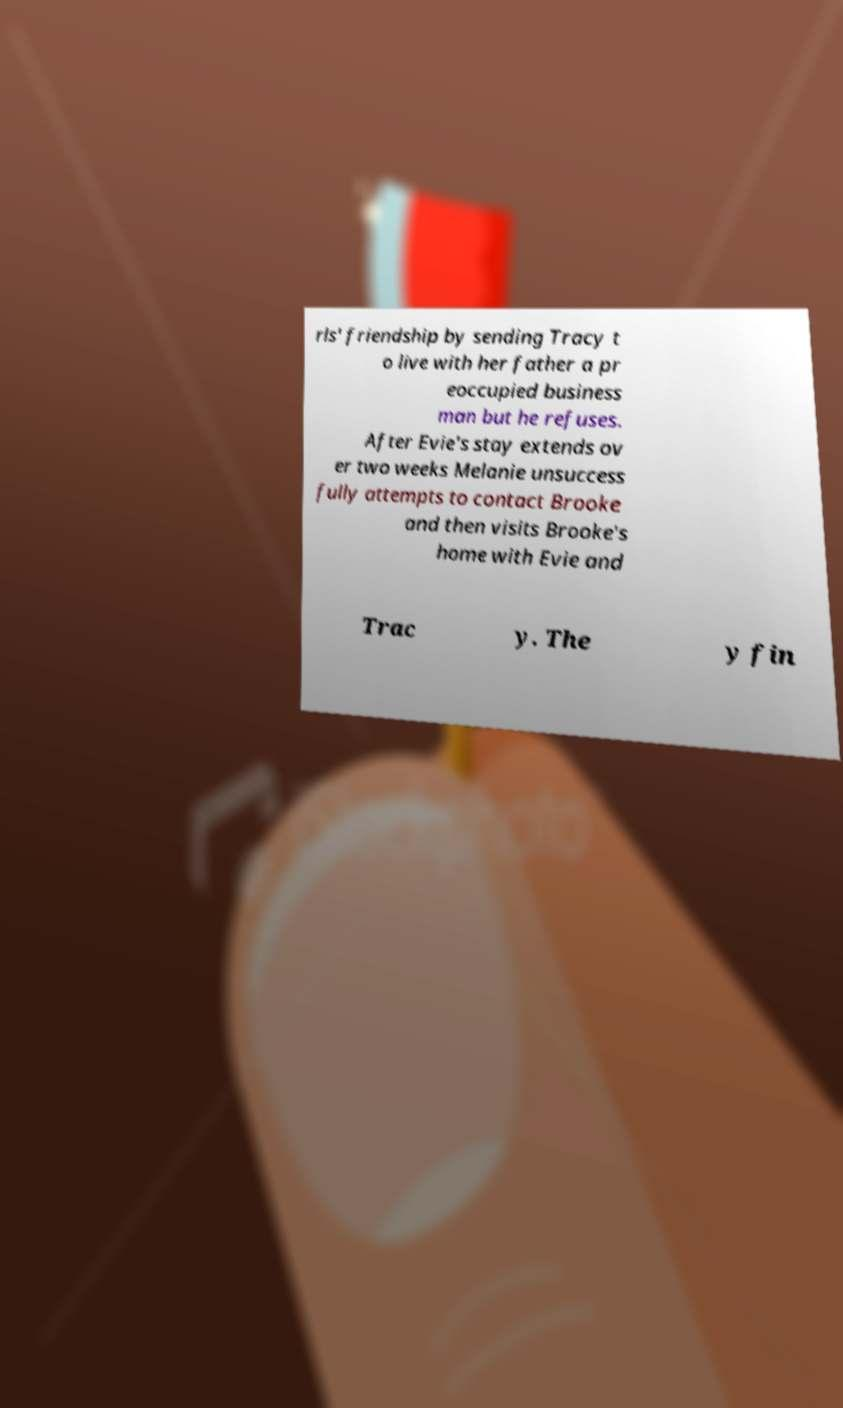Can you accurately transcribe the text from the provided image for me? rls' friendship by sending Tracy t o live with her father a pr eoccupied business man but he refuses. After Evie's stay extends ov er two weeks Melanie unsuccess fully attempts to contact Brooke and then visits Brooke's home with Evie and Trac y. The y fin 